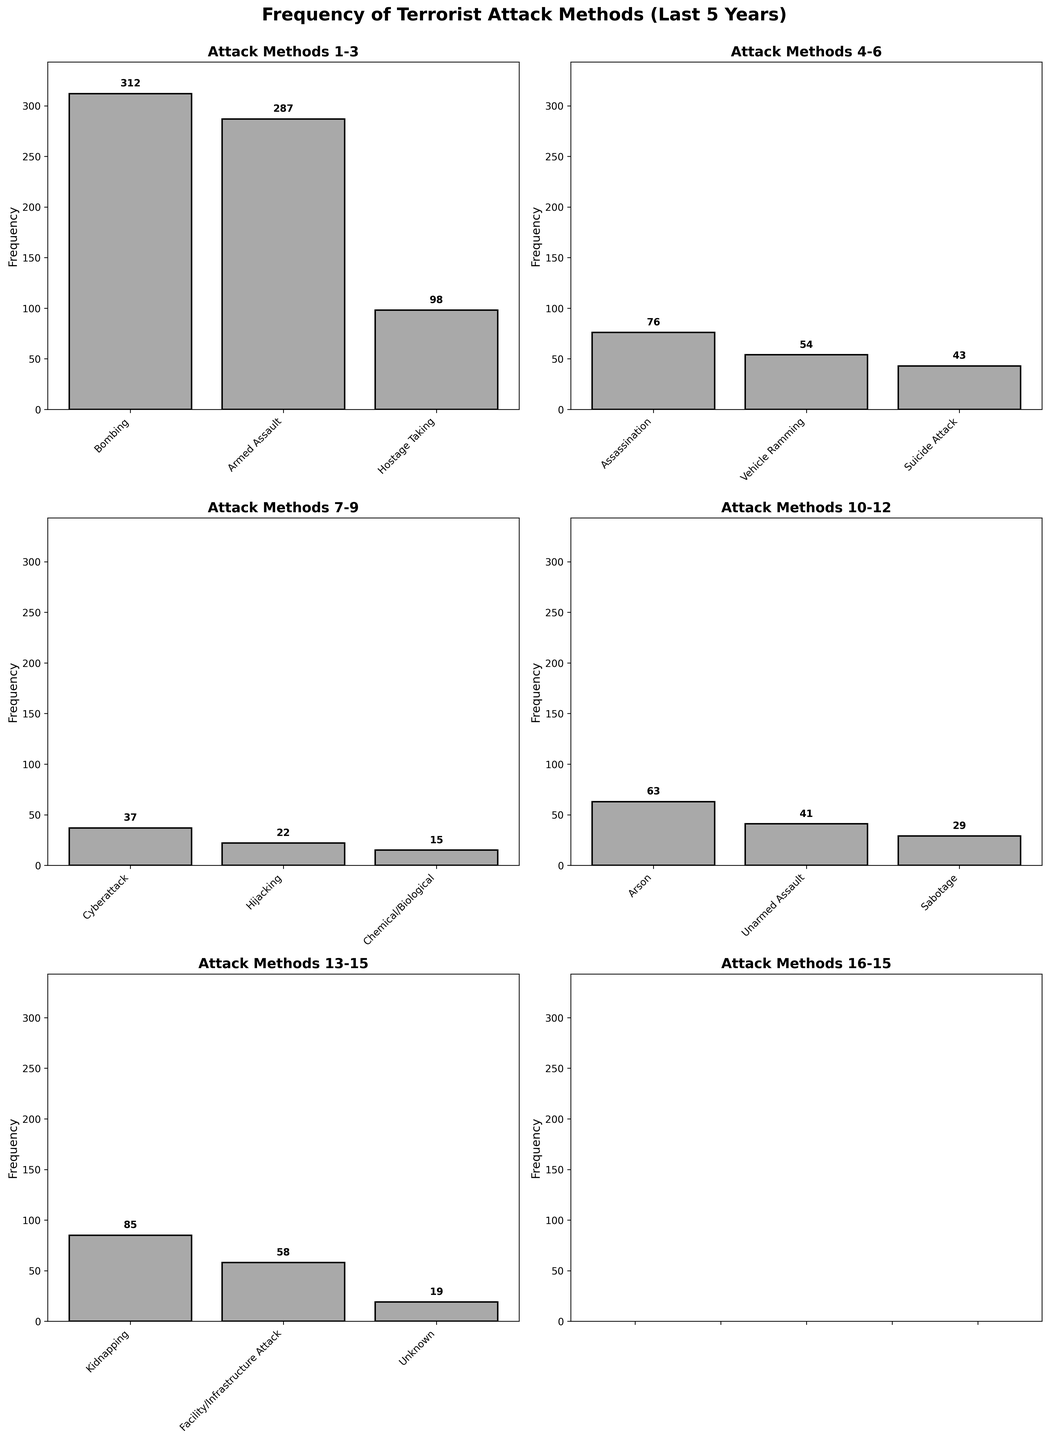What is the title of the figure? The title is displayed at the top center of the figure and reads, "Frequency of Terrorist Attack Methods (Last 5 Years)"
Answer: Frequency of Terrorist Attack Methods (Last 5 Years) Which attack method has the highest frequency according to the figure? By examining the height of the bars in the subplots, the highest bar corresponds to "Bombing," which has a frequency of 312.
Answer: Bombing What is the frequency of "Chemical/Biological" attacks? Look for the bar labeled "Chemical/Biological" and read its height value or the label above it, which shows 15.
Answer: 15 How many types of attack methods are displayed across all subplots? Count the total number of bars across all subplots; there are individual bars for each attack method, totaling 15.
Answer: 15 Compare the frequencies of "Hostage Taking" and "Kidnapping." Which is more frequent and by how much? "Hostage Taking" has a frequency of 98, while "Kidnapping" has a frequency of 85. Subtract 85 from 98 to find the difference, which is 13.
Answer: Hostage Taking by 13 What is the combined frequency of "Arson" and "Cyberattack"? Add the frequencies of both "Arson" (63) and "Cyberattack" (37) to get the total frequency, which is 63 + 37 = 100.
Answer: 100 Which subplot contains the "Assassination" attack method and what is its frequency? Locate the subplot that displays "Assassination;" it is the second subplot from the left on the second row, and the frequency is 76.
Answer: Second subplot, 76 How does the frequency of "Vehicle Ramming" compare to "Suicide Attack"? The frequency of "Vehicle Ramming" is 54, while "Suicide Attack" has a frequency of 43. Comparing these, "Vehicle Ramming" is higher by 54 - 43 = 11.
Answer: Vehicle Ramming by 11 What is the total frequency of all attack methods combined? Sum the frequencies of all the attack methods: 312 + 287 + 98 + 76 + 54 + 43 + 37 + 22 + 15 + 63 + 41 + 29 + 85 + 58 + 19 = 1239.
Answer: 1239 What is the approximate average frequency of the attack methods? Divide the total frequency (1239) by the number of attack methods (15) to find the average, which is 1239 / 15 ≈ 82.6.
Answer: 82.6 